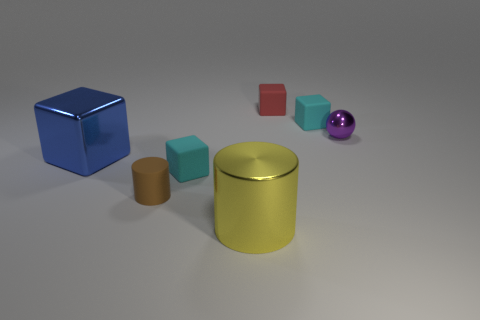The yellow object that is made of the same material as the small purple thing is what shape?
Your answer should be compact. Cylinder. What is the color of the cylinder to the left of the matte block in front of the metal thing left of the large cylinder?
Provide a succinct answer. Brown. Is the number of cyan things that are behind the big cylinder less than the number of yellow shiny things that are to the left of the brown rubber object?
Give a very brief answer. No. Is the shape of the yellow object the same as the tiny red rubber thing?
Make the answer very short. No. How many blue objects have the same size as the metal ball?
Your answer should be compact. 0. Are there fewer blue cubes in front of the yellow object than large purple shiny cubes?
Your response must be concise. No. There is a cube that is behind the cyan thing that is behind the blue thing; how big is it?
Offer a very short reply. Small. How many objects are yellow metallic objects or small purple metal objects?
Provide a succinct answer. 2. Is there a block that has the same color as the small rubber cylinder?
Your answer should be very brief. No. Is the number of cyan matte things less than the number of small red rubber blocks?
Keep it short and to the point. No. 